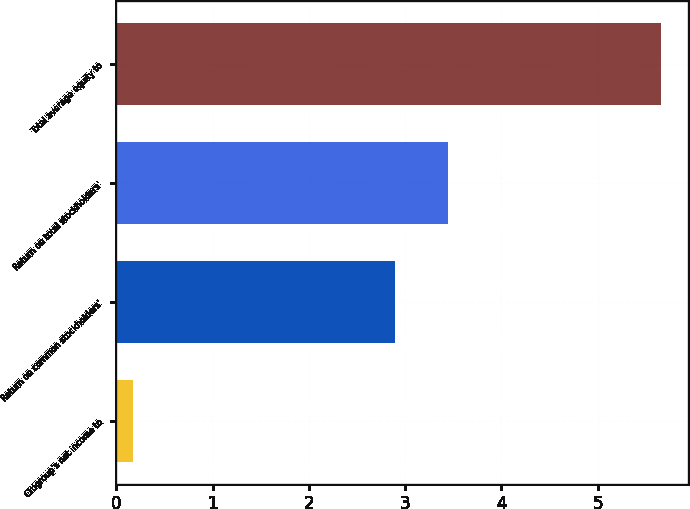Convert chart to OTSL. <chart><loc_0><loc_0><loc_500><loc_500><bar_chart><fcel>Citigroup's net income to<fcel>Return on common stockholders'<fcel>Return on total stockholders'<fcel>Total average equity to<nl><fcel>0.17<fcel>2.9<fcel>3.45<fcel>5.66<nl></chart> 